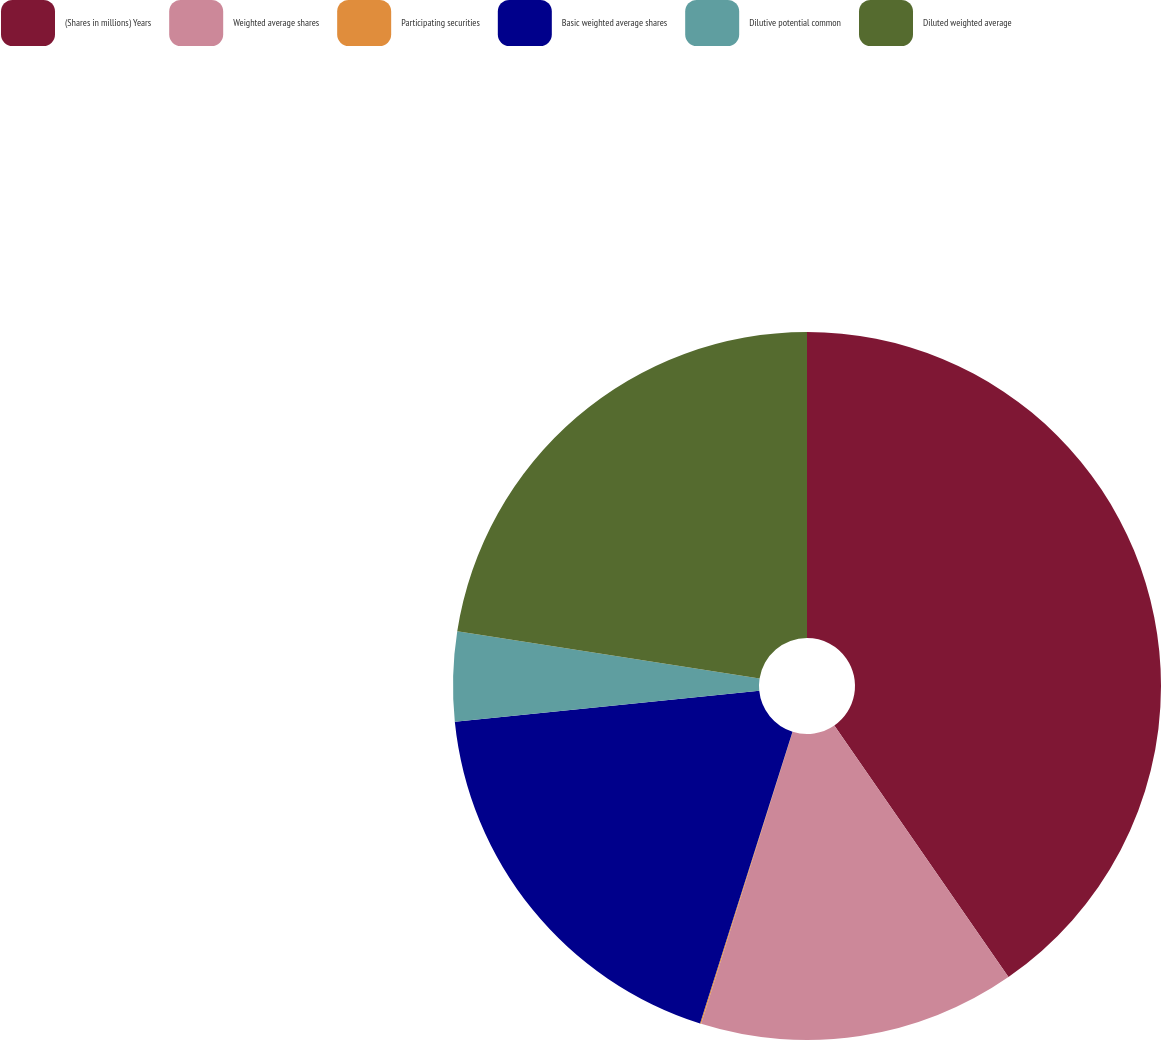Convert chart to OTSL. <chart><loc_0><loc_0><loc_500><loc_500><pie_chart><fcel>(Shares in millions) Years<fcel>Weighted average shares<fcel>Participating securities<fcel>Basic weighted average shares<fcel>Dilutive potential common<fcel>Diluted weighted average<nl><fcel>40.36%<fcel>14.47%<fcel>0.05%<fcel>18.5%<fcel>4.08%<fcel>22.53%<nl></chart> 